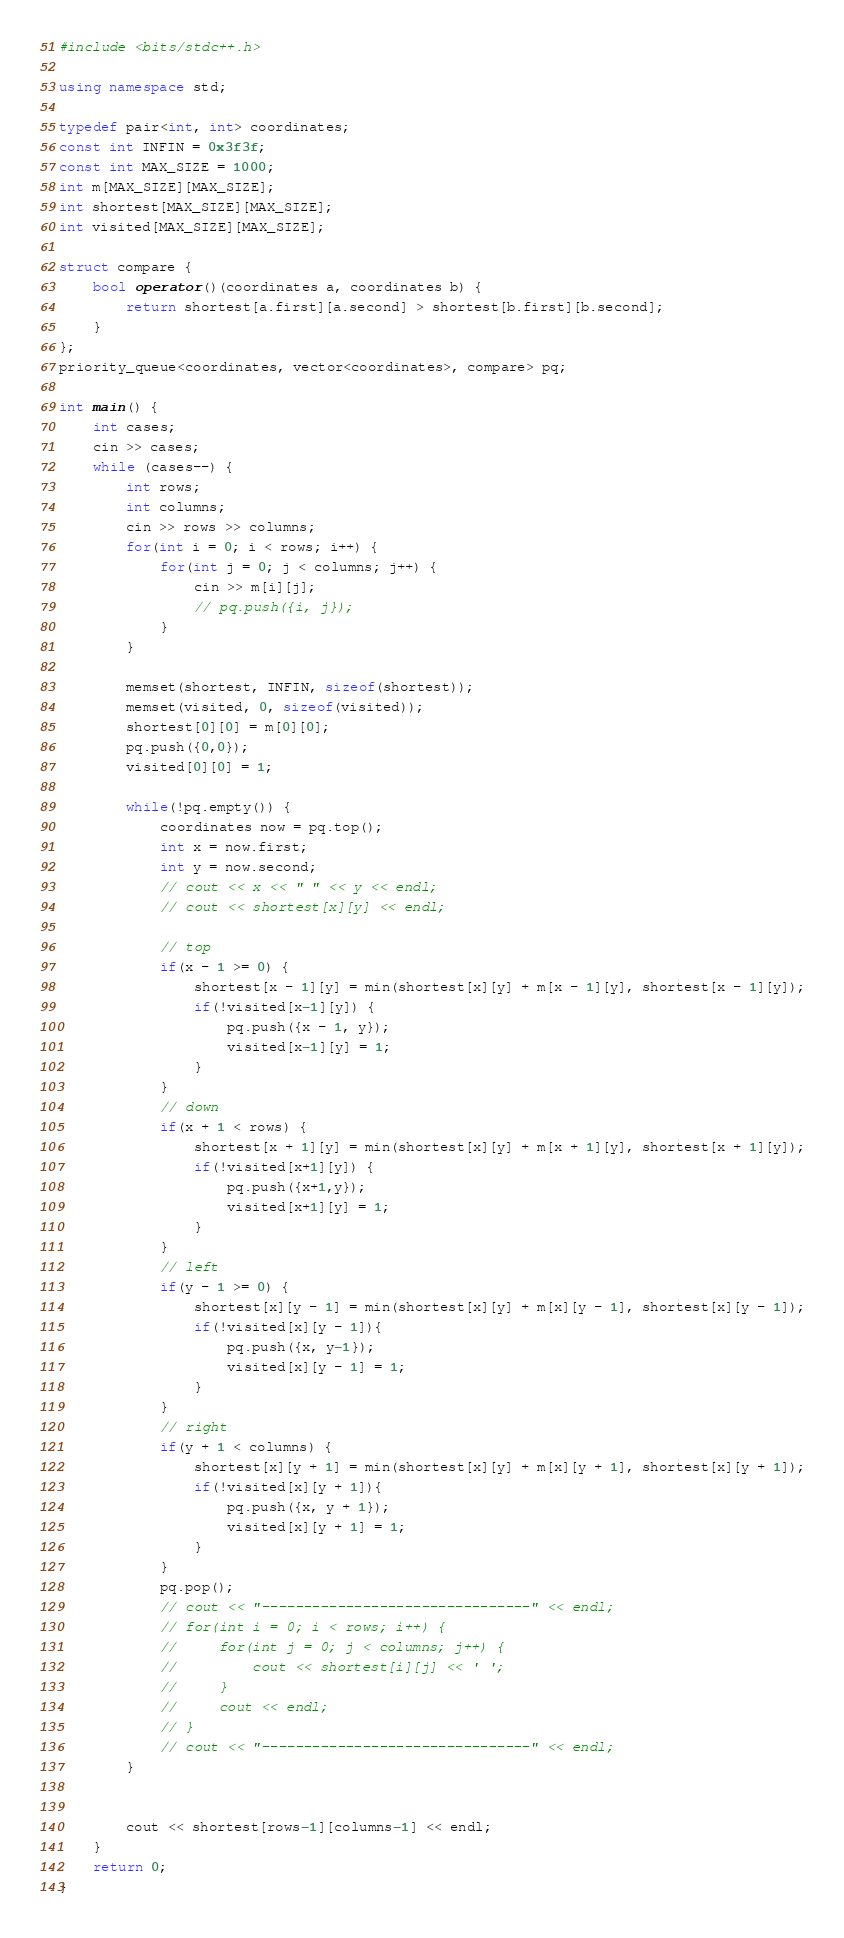Convert code to text. <code><loc_0><loc_0><loc_500><loc_500><_C++_>#include <bits/stdc++.h>

using namespace std;

typedef pair<int, int> coordinates;
const int INFIN = 0x3f3f;
const int MAX_SIZE = 1000;
int m[MAX_SIZE][MAX_SIZE];
int shortest[MAX_SIZE][MAX_SIZE];
int visited[MAX_SIZE][MAX_SIZE];

struct compare {
    bool operator()(coordinates a, coordinates b) {
        return shortest[a.first][a.second] > shortest[b.first][b.second];
    }
};
priority_queue<coordinates, vector<coordinates>, compare> pq;

int main() {
    int cases;
    cin >> cases;
    while (cases--) {
        int rows;
        int columns;
        cin >> rows >> columns;
        for(int i = 0; i < rows; i++) {
            for(int j = 0; j < columns; j++) {
                cin >> m[i][j];
                // pq.push({i, j});
            }
        }
        
        memset(shortest, INFIN, sizeof(shortest));
        memset(visited, 0, sizeof(visited));
        shortest[0][0] = m[0][0];
        pq.push({0,0});
        visited[0][0] = 1;

        while(!pq.empty()) {
            coordinates now = pq.top();
            int x = now.first;
            int y = now.second;
            // cout << x << " " << y << endl;
            // cout << shortest[x][y] << endl;
            
            // top
            if(x - 1 >= 0) {
                shortest[x - 1][y] = min(shortest[x][y] + m[x - 1][y], shortest[x - 1][y]);
                if(!visited[x-1][y]) {
                    pq.push({x - 1, y});
                    visited[x-1][y] = 1;
                }
            }
            // down
            if(x + 1 < rows) {
                shortest[x + 1][y] = min(shortest[x][y] + m[x + 1][y], shortest[x + 1][y]);
                if(!visited[x+1][y]) {
                    pq.push({x+1,y});
                    visited[x+1][y] = 1;
                }
            }
            // left
            if(y - 1 >= 0) {
                shortest[x][y - 1] = min(shortest[x][y] + m[x][y - 1], shortest[x][y - 1]);
                if(!visited[x][y - 1]){
                    pq.push({x, y-1});
                    visited[x][y - 1] = 1;
                }
            }
            // right
            if(y + 1 < columns) {
                shortest[x][y + 1] = min(shortest[x][y] + m[x][y + 1], shortest[x][y + 1]);
                if(!visited[x][y + 1]){
                    pq.push({x, y + 1});
                    visited[x][y + 1] = 1;
                }
            }
            pq.pop();
            // cout << "--------------------------------" << endl;
            // for(int i = 0; i < rows; i++) {
            //     for(int j = 0; j < columns; j++) {
            //         cout << shortest[i][j] << ' ';
            //     }
            //     cout << endl;
            // }
            // cout << "--------------------------------" << endl;
        }
        

        cout << shortest[rows-1][columns-1] << endl;
    }
    return 0;
}</code> 